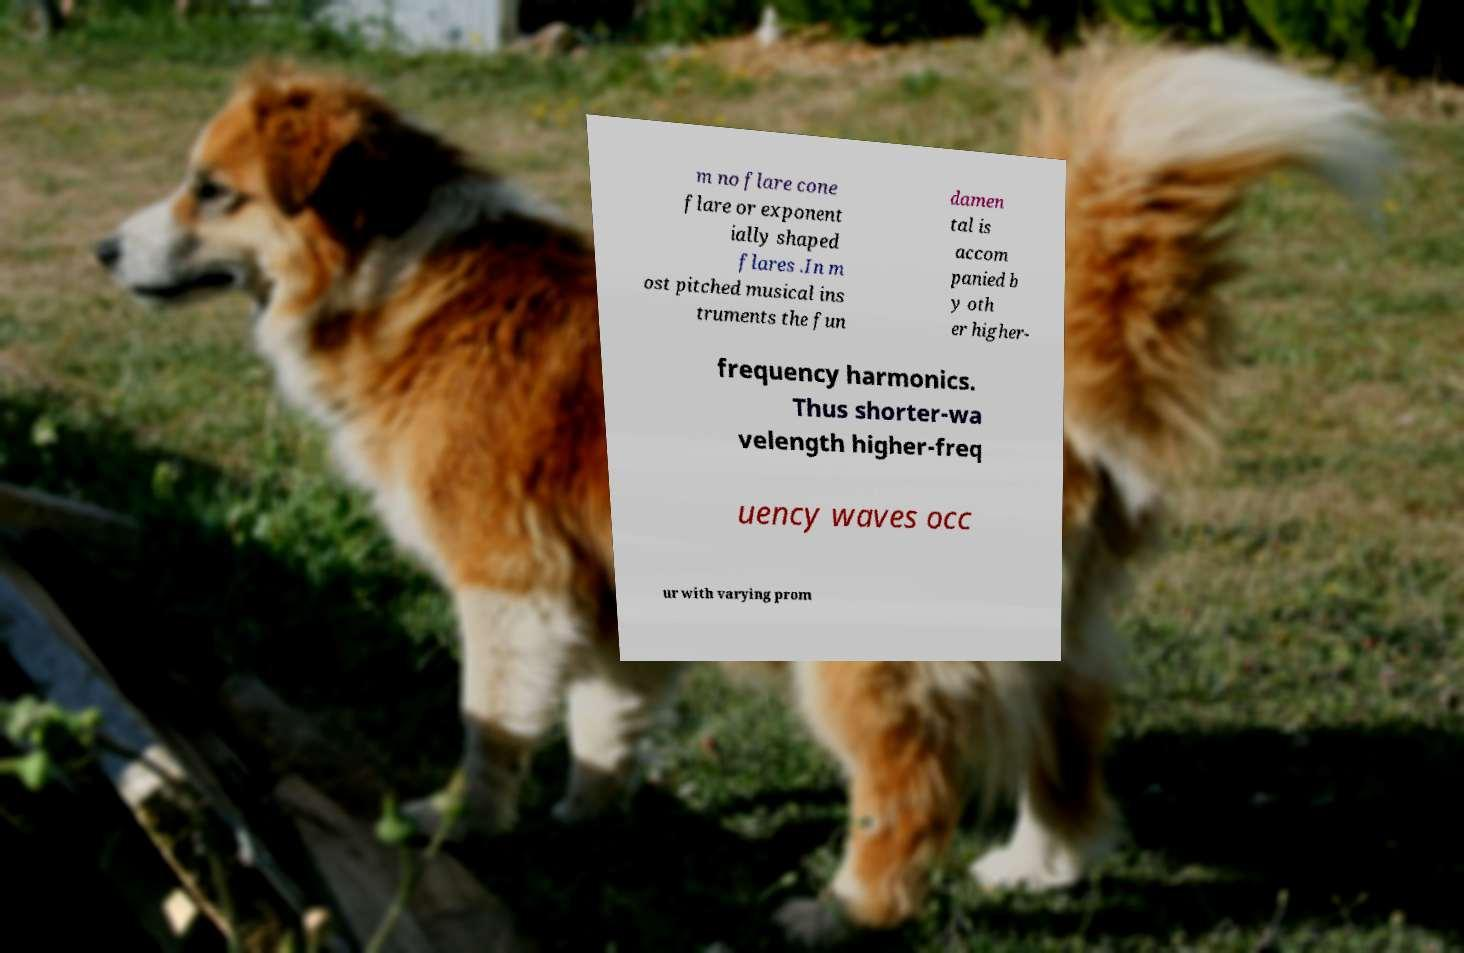Can you accurately transcribe the text from the provided image for me? m no flare cone flare or exponent ially shaped flares .In m ost pitched musical ins truments the fun damen tal is accom panied b y oth er higher- frequency harmonics. Thus shorter-wa velength higher-freq uency waves occ ur with varying prom 